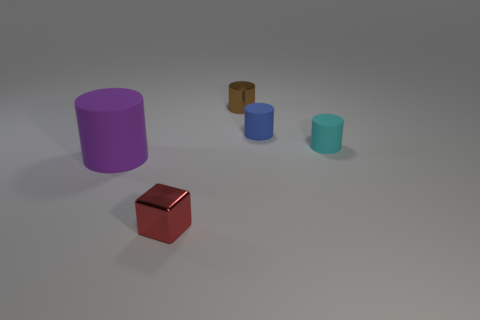Add 5 cyan things. How many objects exist? 10 Subtract all cylinders. How many objects are left? 1 Subtract 0 purple spheres. How many objects are left? 5 Subtract all small cyan cubes. Subtract all small blue cylinders. How many objects are left? 4 Add 1 rubber cylinders. How many rubber cylinders are left? 4 Add 3 small matte objects. How many small matte objects exist? 5 